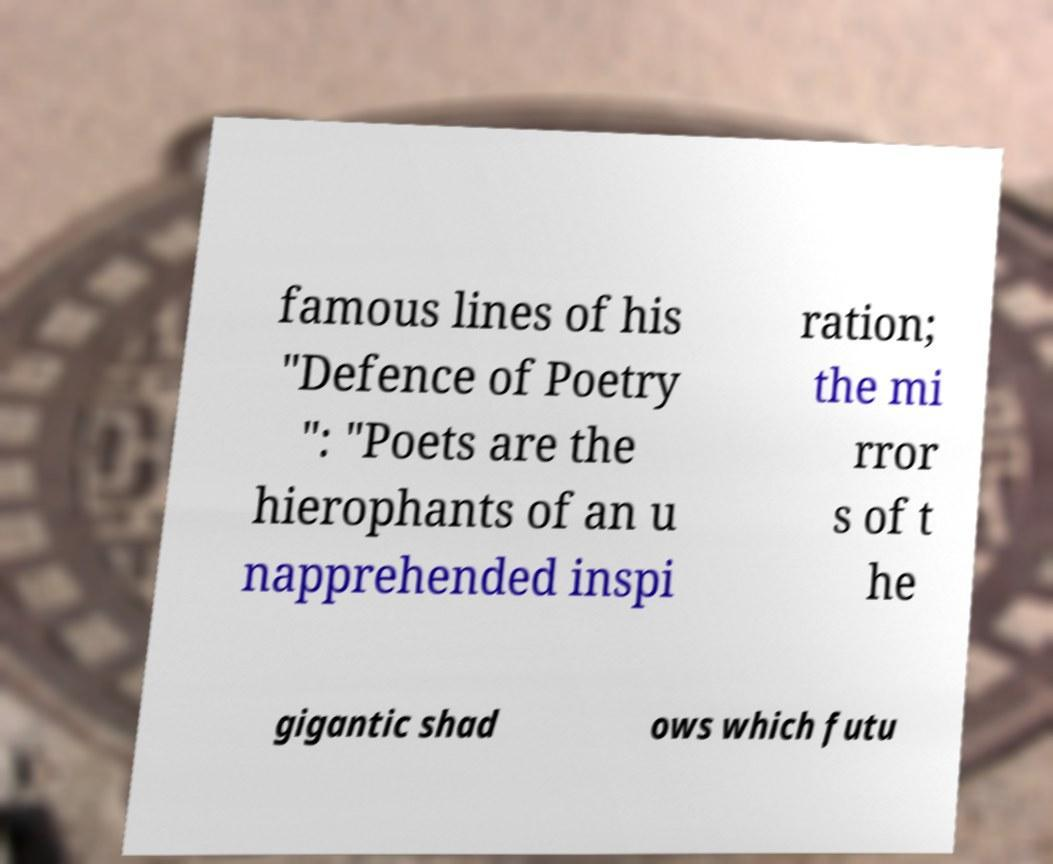Please read and relay the text visible in this image. What does it say? famous lines of his "Defence of Poetry ": "Poets are the hierophants of an u napprehended inspi ration; the mi rror s of t he gigantic shad ows which futu 